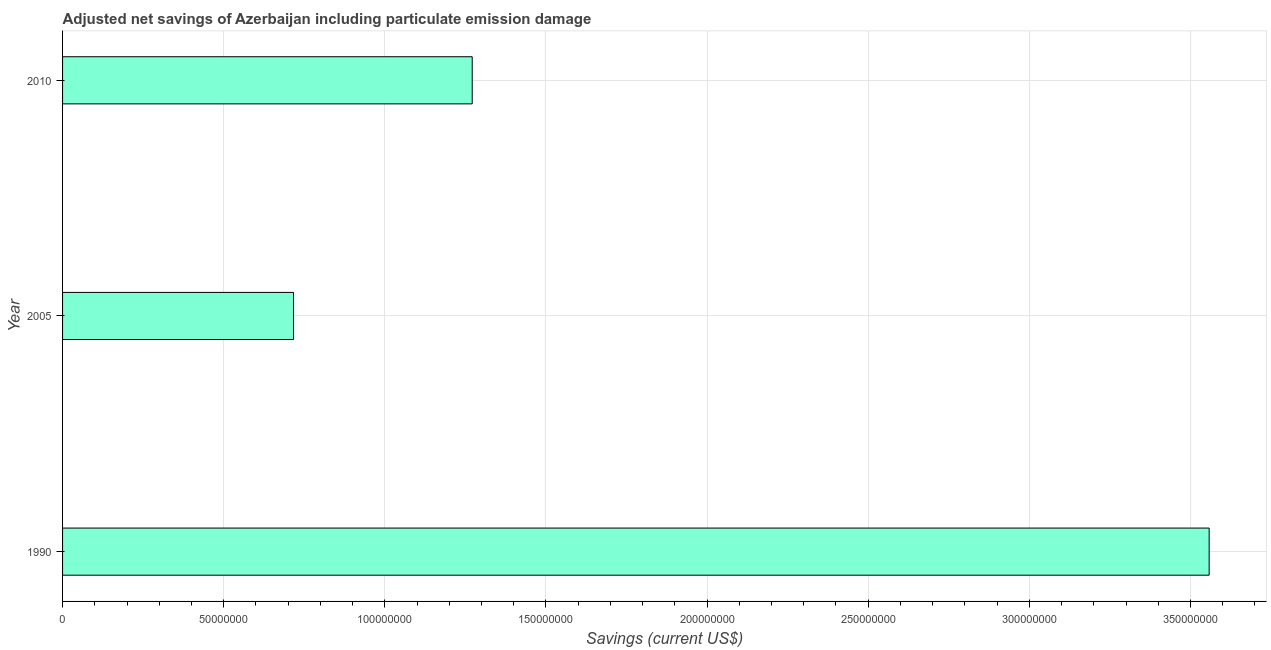Does the graph contain any zero values?
Make the answer very short. No. What is the title of the graph?
Ensure brevity in your answer.  Adjusted net savings of Azerbaijan including particulate emission damage. What is the label or title of the X-axis?
Give a very brief answer. Savings (current US$). What is the label or title of the Y-axis?
Provide a succinct answer. Year. What is the adjusted net savings in 2010?
Give a very brief answer. 1.27e+08. Across all years, what is the maximum adjusted net savings?
Your response must be concise. 3.56e+08. Across all years, what is the minimum adjusted net savings?
Make the answer very short. 7.17e+07. In which year was the adjusted net savings maximum?
Offer a very short reply. 1990. In which year was the adjusted net savings minimum?
Your answer should be very brief. 2005. What is the sum of the adjusted net savings?
Keep it short and to the point. 5.55e+08. What is the difference between the adjusted net savings in 1990 and 2005?
Offer a very short reply. 2.84e+08. What is the average adjusted net savings per year?
Offer a terse response. 1.85e+08. What is the median adjusted net savings?
Give a very brief answer. 1.27e+08. Do a majority of the years between 1990 and 2010 (inclusive) have adjusted net savings greater than 120000000 US$?
Offer a very short reply. Yes. What is the ratio of the adjusted net savings in 1990 to that in 2010?
Keep it short and to the point. 2.8. Is the adjusted net savings in 1990 less than that in 2010?
Provide a short and direct response. No. Is the difference between the adjusted net savings in 1990 and 2005 greater than the difference between any two years?
Provide a succinct answer. Yes. What is the difference between the highest and the second highest adjusted net savings?
Your answer should be very brief. 2.29e+08. What is the difference between the highest and the lowest adjusted net savings?
Provide a succinct answer. 2.84e+08. What is the difference between two consecutive major ticks on the X-axis?
Keep it short and to the point. 5.00e+07. Are the values on the major ticks of X-axis written in scientific E-notation?
Provide a short and direct response. No. What is the Savings (current US$) in 1990?
Provide a succinct answer. 3.56e+08. What is the Savings (current US$) of 2005?
Give a very brief answer. 7.17e+07. What is the Savings (current US$) in 2010?
Provide a succinct answer. 1.27e+08. What is the difference between the Savings (current US$) in 1990 and 2005?
Offer a very short reply. 2.84e+08. What is the difference between the Savings (current US$) in 1990 and 2010?
Offer a terse response. 2.29e+08. What is the difference between the Savings (current US$) in 2005 and 2010?
Give a very brief answer. -5.54e+07. What is the ratio of the Savings (current US$) in 1990 to that in 2005?
Your answer should be compact. 4.96. What is the ratio of the Savings (current US$) in 1990 to that in 2010?
Offer a very short reply. 2.8. What is the ratio of the Savings (current US$) in 2005 to that in 2010?
Provide a succinct answer. 0.56. 